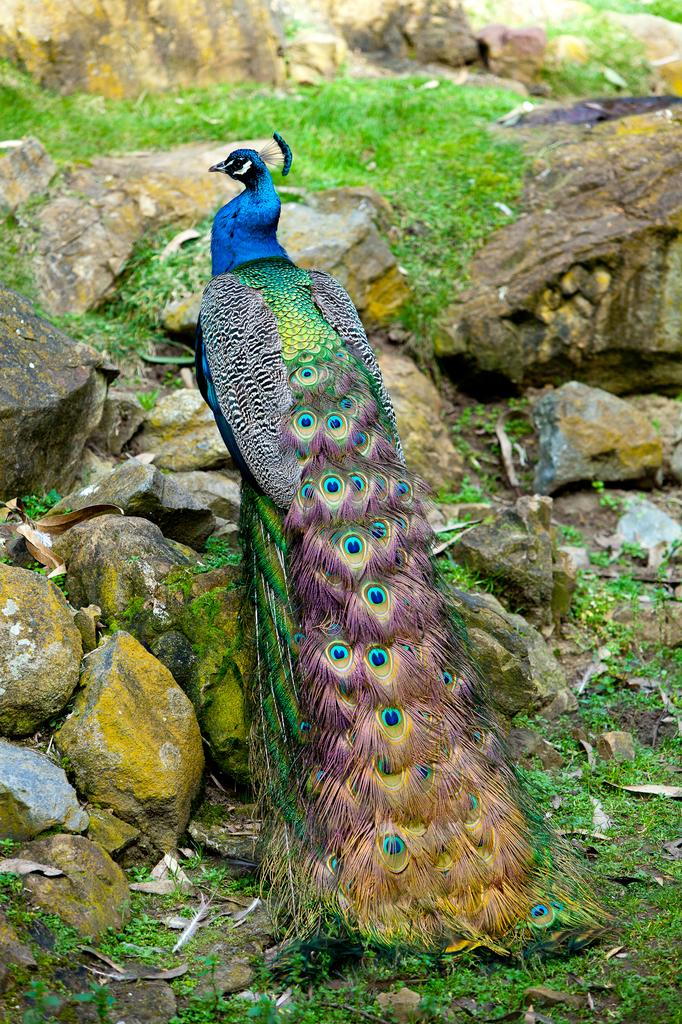What is the main subject in the center of the image? There is a peacock in the center of the image. What type of natural elements can be seen in the image? Stones, a rock, grass, and quills are visible in the image. How does the peacock show its disgust in the image? The peacock does not show any signs of disgust in the image; it is simply standing on the ground. 